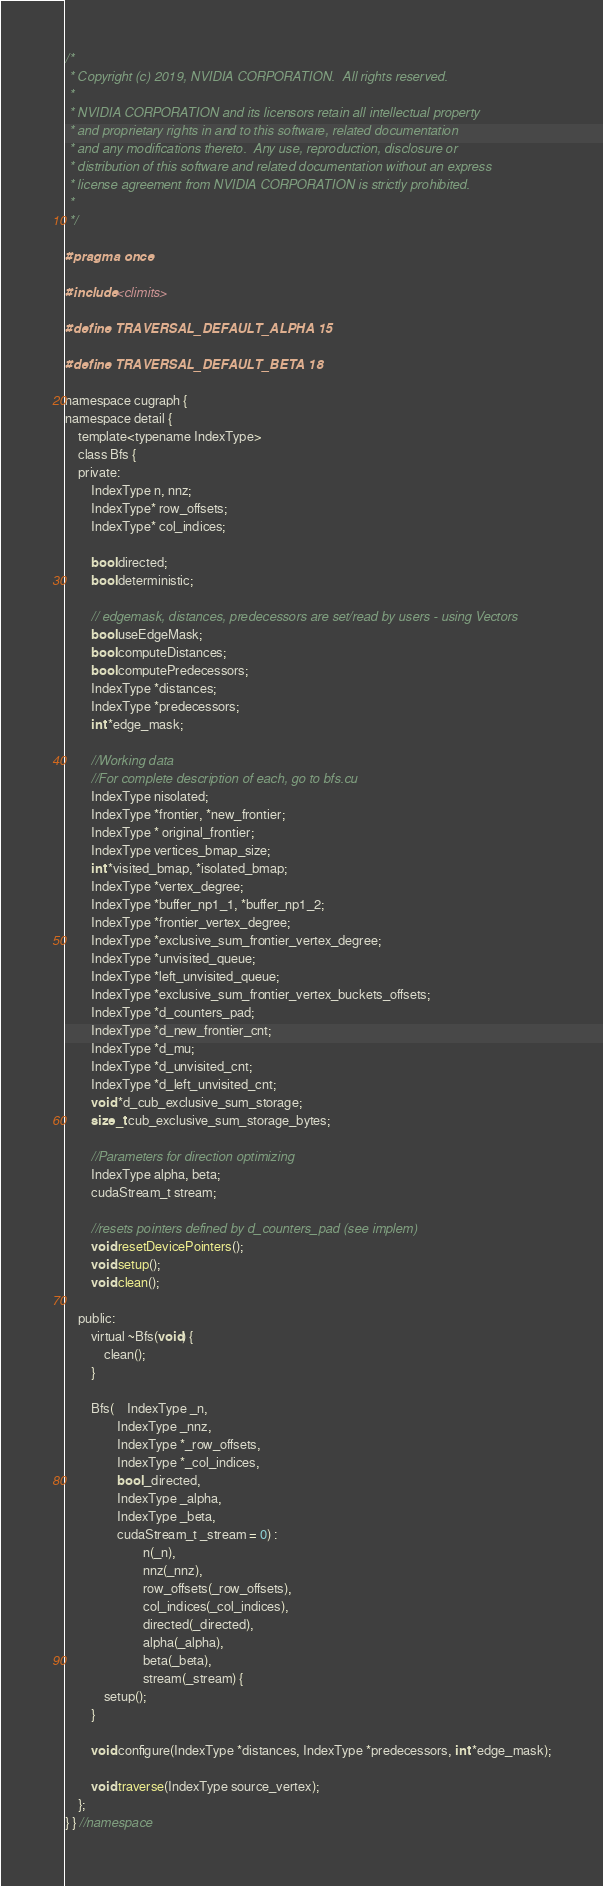<code> <loc_0><loc_0><loc_500><loc_500><_Cuda_>/*
 * Copyright (c) 2019, NVIDIA CORPORATION.  All rights reserved.
 *
 * NVIDIA CORPORATION and its licensors retain all intellectual property
 * and proprietary rights in and to this software, related documentation
 * and any modifications thereto.  Any use, reproduction, disclosure or
 * distribution of this software and related documentation without an express
 * license agreement from NVIDIA CORPORATION is strictly prohibited.
 *
 */

#pragma once

#include <climits> 

#define TRAVERSAL_DEFAULT_ALPHA 15

#define TRAVERSAL_DEFAULT_BETA 18

namespace cugraph { 
namespace detail {
	template<typename IndexType>
	class Bfs {
	private:
		IndexType n, nnz;
		IndexType* row_offsets;
		IndexType* col_indices;

		bool directed;
		bool deterministic;

		// edgemask, distances, predecessors are set/read by users - using Vectors
		bool useEdgeMask;
		bool computeDistances;
		bool computePredecessors;
		IndexType *distances;
		IndexType *predecessors;
		int *edge_mask;

		//Working data
		//For complete description of each, go to bfs.cu
		IndexType nisolated;
		IndexType *frontier, *new_frontier;
		IndexType * original_frontier;
		IndexType vertices_bmap_size;
		int *visited_bmap, *isolated_bmap;
		IndexType *vertex_degree;
		IndexType *buffer_np1_1, *buffer_np1_2;
		IndexType *frontier_vertex_degree;
		IndexType *exclusive_sum_frontier_vertex_degree;
		IndexType *unvisited_queue;
		IndexType *left_unvisited_queue;
		IndexType *exclusive_sum_frontier_vertex_buckets_offsets;
		IndexType *d_counters_pad;
		IndexType *d_new_frontier_cnt;
		IndexType *d_mu;
		IndexType *d_unvisited_cnt;
		IndexType *d_left_unvisited_cnt;
		void *d_cub_exclusive_sum_storage;
		size_t cub_exclusive_sum_storage_bytes;

		//Parameters for direction optimizing
		IndexType alpha, beta;
		cudaStream_t stream;

		//resets pointers defined by d_counters_pad (see implem)
		void resetDevicePointers();
		void setup();
		void clean();

	public:
		virtual ~Bfs(void) {
			clean();
		}

		Bfs(	IndexType _n,
				IndexType _nnz,
				IndexType *_row_offsets,
				IndexType *_col_indices,
				bool _directed,
				IndexType _alpha,
				IndexType _beta,
				cudaStream_t _stream = 0) :
						n(_n),
						nnz(_nnz),
						row_offsets(_row_offsets),
						col_indices(_col_indices),
						directed(_directed),
						alpha(_alpha),
						beta(_beta),
						stream(_stream) {
			setup();
		}

		void configure(IndexType *distances, IndexType *predecessors, int *edge_mask);

		void traverse(IndexType source_vertex);
	};
} } //namespace

</code> 